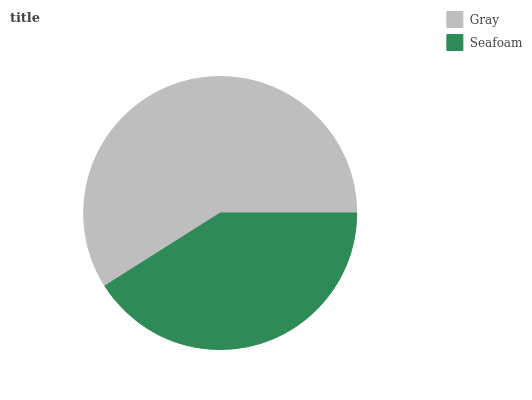Is Seafoam the minimum?
Answer yes or no. Yes. Is Gray the maximum?
Answer yes or no. Yes. Is Seafoam the maximum?
Answer yes or no. No. Is Gray greater than Seafoam?
Answer yes or no. Yes. Is Seafoam less than Gray?
Answer yes or no. Yes. Is Seafoam greater than Gray?
Answer yes or no. No. Is Gray less than Seafoam?
Answer yes or no. No. Is Gray the high median?
Answer yes or no. Yes. Is Seafoam the low median?
Answer yes or no. Yes. Is Seafoam the high median?
Answer yes or no. No. Is Gray the low median?
Answer yes or no. No. 